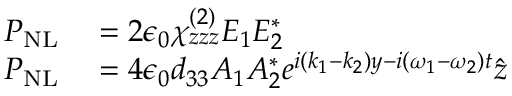<formula> <loc_0><loc_0><loc_500><loc_500>\begin{array} { r l } { P _ { N L } } & = 2 \epsilon _ { 0 } \chi _ { z z z } ^ { ( 2 ) } E _ { 1 } E _ { 2 } ^ { * } } \\ { P _ { N L } } & = 4 \epsilon _ { 0 } d _ { 3 3 } A _ { 1 } A _ { 2 } ^ { * } e ^ { i ( k _ { 1 } - k _ { 2 } ) y - i ( \omega _ { 1 } - \omega _ { 2 } ) t } \hat { z } } \end{array}</formula> 